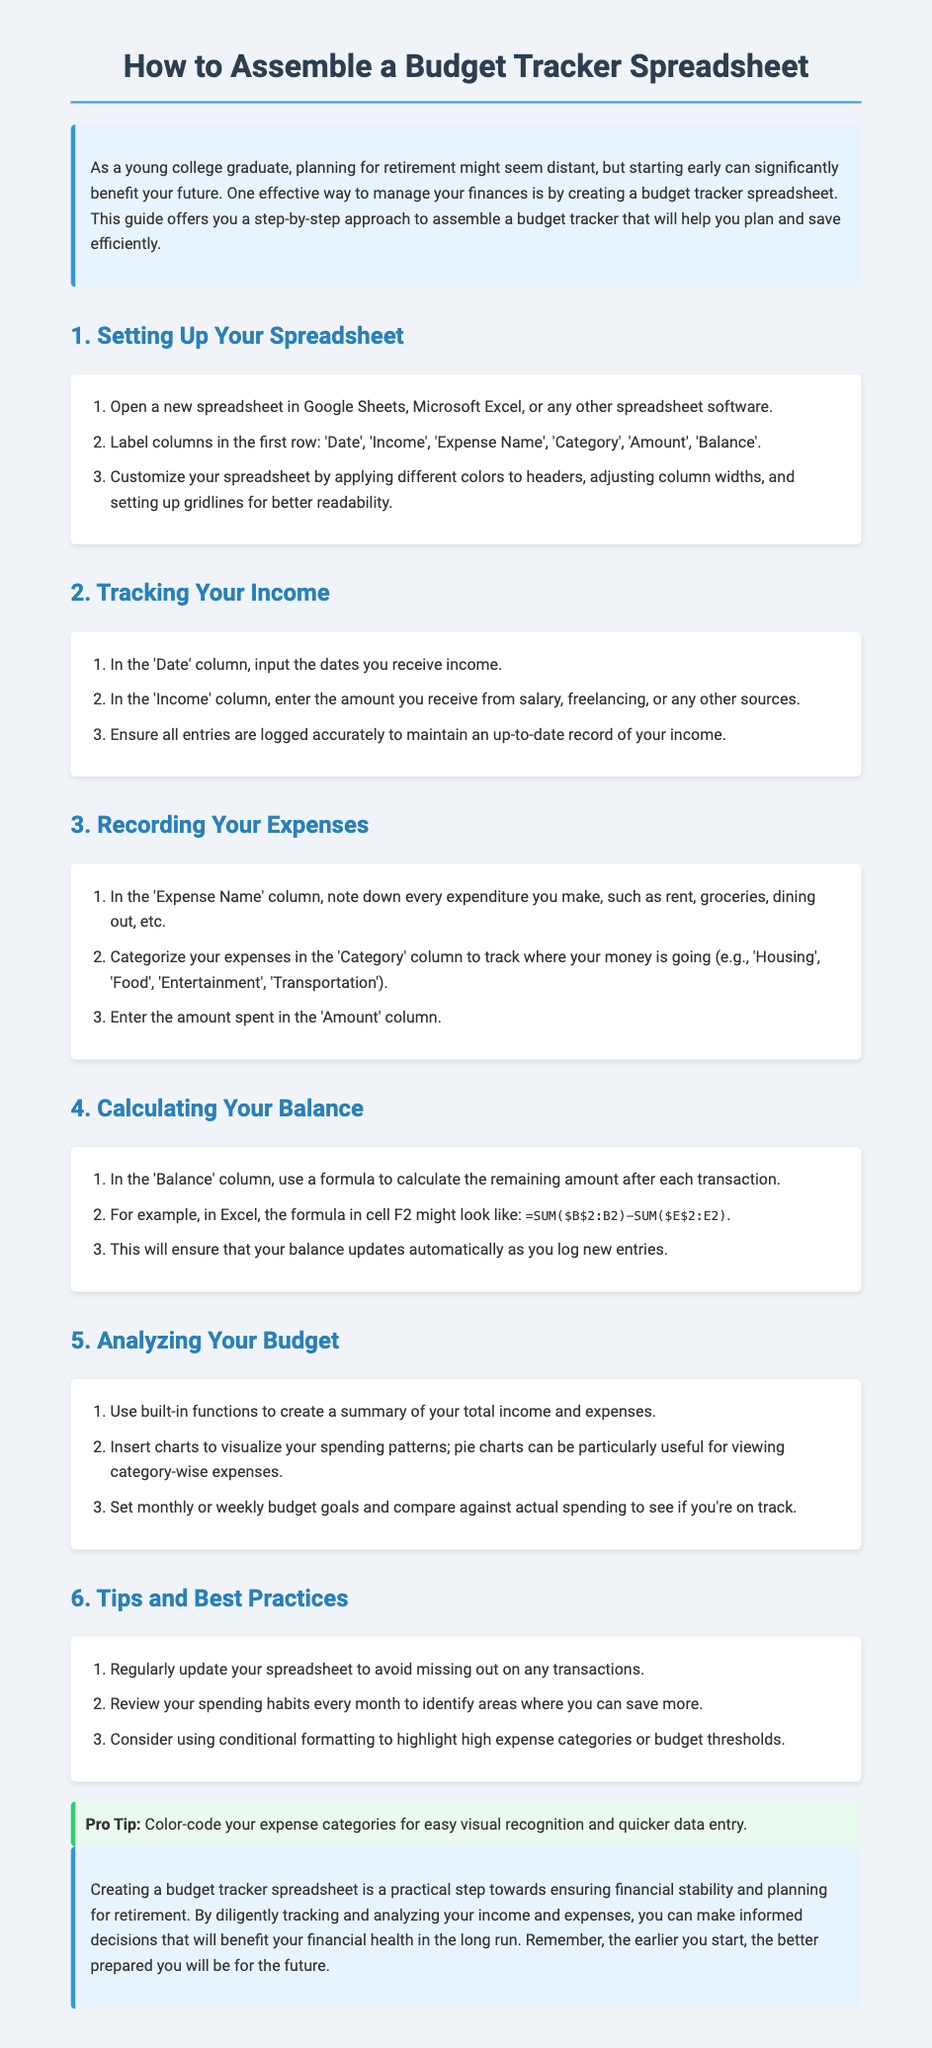what is the title of the document? The title is clearly stated at the top of the document.
Answer: How to Assemble a Budget Tracker Spreadsheet what software can you use to create the spreadsheet? The document mentions Google Sheets, Microsoft Excel, or any other spreadsheet software.
Answer: Google Sheets, Microsoft Excel what are the first row labels for the spreadsheet? The document lists the required column labels to be included in the first row.
Answer: Date, Income, Expense Name, Category, Amount, Balance what formula is suggested for calculating the balance? The document provides a specific formula example for balance calculation.
Answer: =SUM($B$2:B2)-SUM($E$2:E2) how many steps are there in this guide? The document outlines a total of six steps for assembling the budget tracker.
Answer: 6 what is the recommended frequency for updating the spreadsheet? The document advises on maintaining regular updates to the spreadsheet.
Answer: Regularly what type of chart is suggested for visualizing spending patterns? The document recommends a specific type of chart to analyze spending.
Answer: Pie charts what is a pro tip mentioned in the document? The document includes a special suggestion for enhancing visual organization.
Answer: Color-code your expense categories 